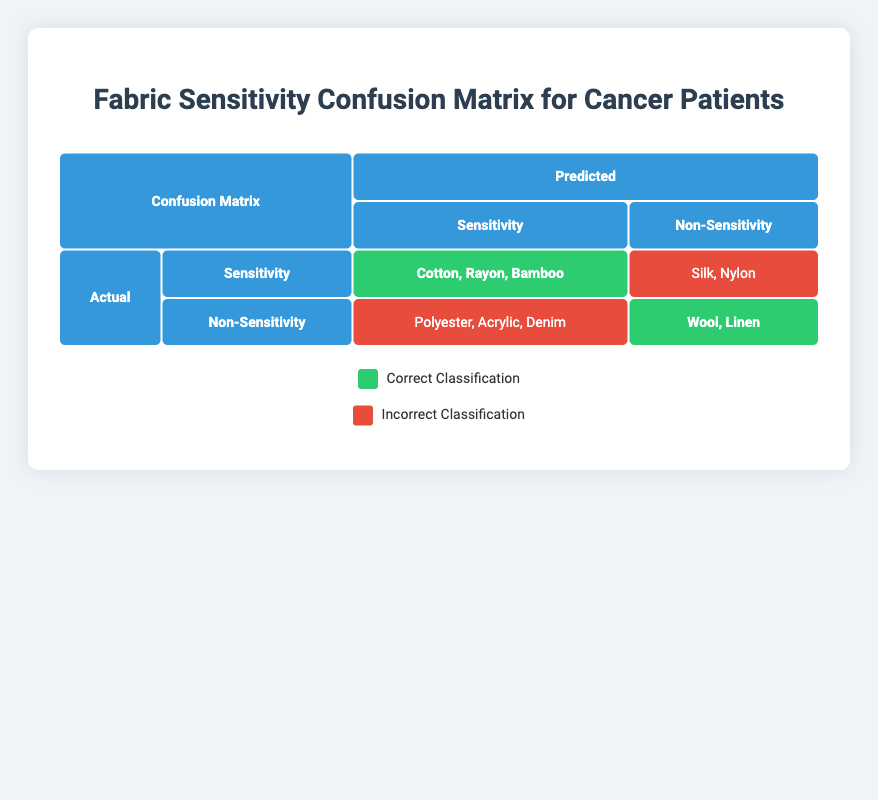What are the actual sensitive fabrics that were correctly classified? From the table, the correct classifications in the "Sensitivity" row of the "Actual" section include Cotton, Rayon, and Bamboo. These fabrics are listed under the correct category.
Answer: Cotton, Rayon, Bamboo How many fabrics were incorrectly classified as non-sensitive? In the "Non-Sensitivity" row of the "Actual" section, there are three fabrics listed under incorrect classifications: Polyester, Acrylic, and Denim.
Answer: 3 Is Silk classified correctly based on the table? Silk appears in the row under the "Sensitivity" column but is placed in the "incorrect" classification area. This means Silk is not classified correctly.
Answer: No What percentage of actual sensitivity fabrics were correctly classified? Out of five actual sensitivity fabrics, three (Cotton, Rayon, Bamboo) were classified correctly. The percentage is (3/5) * 100 = 60%.
Answer: 60% Which non-sensitive fabric was incorrectly classified that is actually sensitive? The incorrect classifications under "Non-Sensitivity" include Polyester, Acrylic, and Denim, of which Denim is the one that was incorrectly predicted as non-sensitive but is in fact not sensitive.
Answer: Denim How many fabrics are classified correctly in total? For correct classifications, we have Cotton, Rayon, Bamboo (3 correct in sensitivity) and Wool, Linen (2 correct in non-sensitivity), totaling 5 correct classifications.
Answer: 5 Did any actual non-sensitive fabrics get misclassified as sensitivity? Yes, in the "Actual" section's "Non-Sensitivity" row, Polyester, Acrylic, and Denim were all incorrectly classified as sensitivity fabrics.
Answer: Yes What is the ratio of correctly classified sensitive fabrics to incorrectly classified non-sensitive fabrics? There are 3 correctly classified sensitive fabrics (Cotton, Rayon, Bamboo) and 3 incorrectly classified non-sensitive fabrics (Polyester, Acrylic, Denim). Thus, the ratio is 3:3, which simplifies to 1:1.
Answer: 1:1 